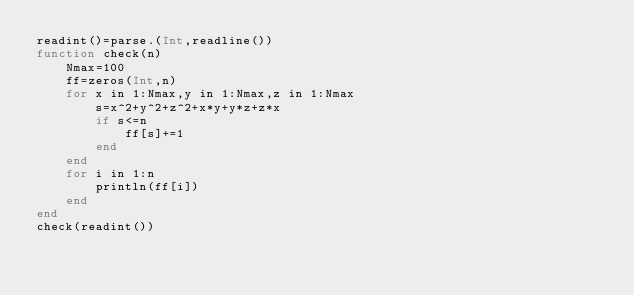<code> <loc_0><loc_0><loc_500><loc_500><_Julia_>readint()=parse.(Int,readline())
function check(n)
    Nmax=100
    ff=zeros(Int,n)
    for x in 1:Nmax,y in 1:Nmax,z in 1:Nmax
        s=x^2+y^2+z^2+x*y+y*z+z*x
        if s<=n
            ff[s]+=1
        end
    end
    for i in 1:n
        println(ff[i])
    end
end
check(readint())</code> 